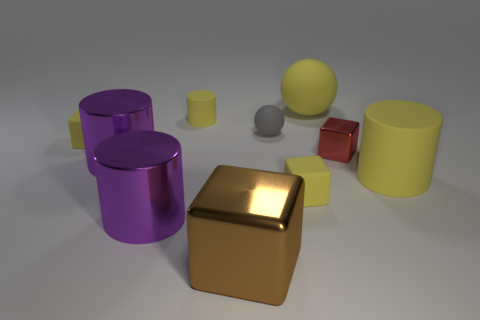Subtract all tiny blocks. How many blocks are left? 1 Subtract all green balls. How many yellow cubes are left? 2 Subtract all red cubes. How many cubes are left? 3 Subtract all spheres. How many objects are left? 8 Subtract 2 cylinders. How many cylinders are left? 2 Subtract all green cylinders. Subtract all red blocks. How many cylinders are left? 4 Subtract all tiny yellow cylinders. Subtract all small red metal objects. How many objects are left? 8 Add 2 matte blocks. How many matte blocks are left? 4 Add 9 small matte cylinders. How many small matte cylinders exist? 10 Subtract 0 blue cylinders. How many objects are left? 10 